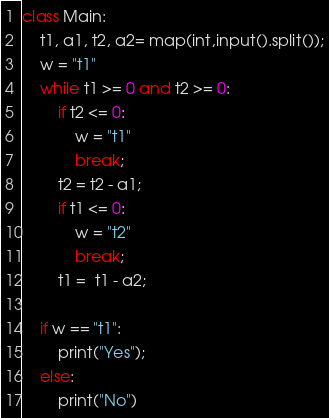Convert code to text. <code><loc_0><loc_0><loc_500><loc_500><_Python_>
class Main:
    t1, a1, t2, a2= map(int,input().split());
    w = "t1"
    while t1 >= 0 and t2 >= 0:
        if t2 <= 0:
            w = "t1"
            break;
        t2 = t2 - a1;
        if t1 <= 0:
            w = "t2"
            break;
        t1 =  t1 - a2;

    if w == "t1":
        print("Yes");
    else:
        print("No")

</code> 